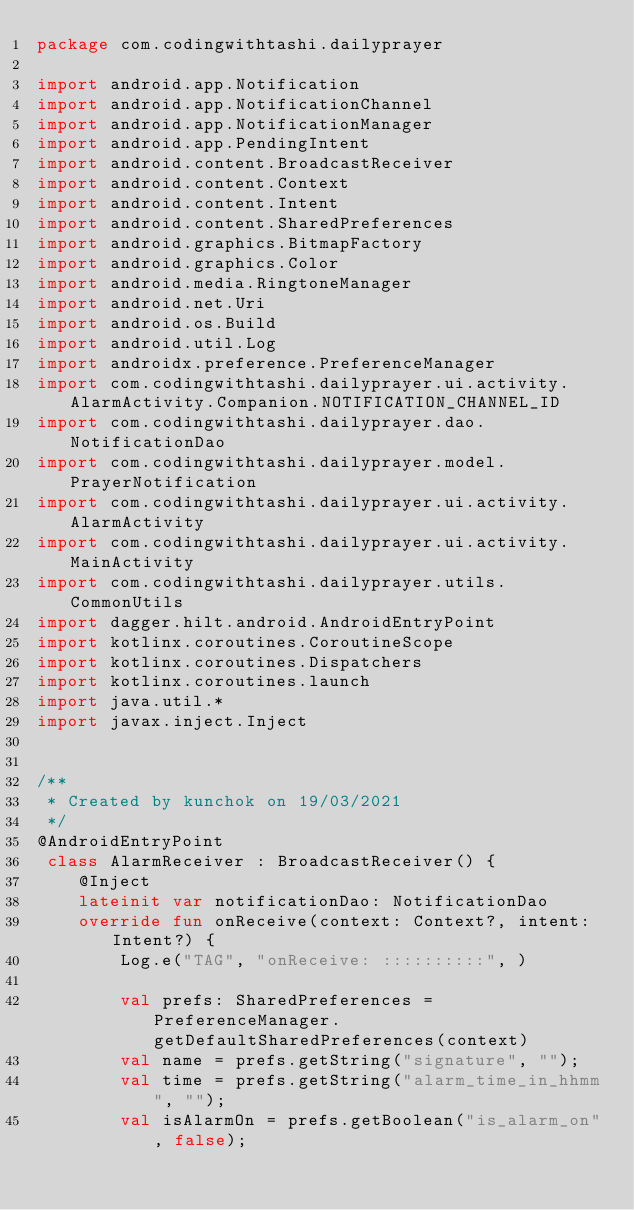Convert code to text. <code><loc_0><loc_0><loc_500><loc_500><_Kotlin_>package com.codingwithtashi.dailyprayer

import android.app.Notification
import android.app.NotificationChannel
import android.app.NotificationManager
import android.app.PendingIntent
import android.content.BroadcastReceiver
import android.content.Context
import android.content.Intent
import android.content.SharedPreferences
import android.graphics.BitmapFactory
import android.graphics.Color
import android.media.RingtoneManager
import android.net.Uri
import android.os.Build
import android.util.Log
import androidx.preference.PreferenceManager
import com.codingwithtashi.dailyprayer.ui.activity.AlarmActivity.Companion.NOTIFICATION_CHANNEL_ID
import com.codingwithtashi.dailyprayer.dao.NotificationDao
import com.codingwithtashi.dailyprayer.model.PrayerNotification
import com.codingwithtashi.dailyprayer.ui.activity.AlarmActivity
import com.codingwithtashi.dailyprayer.ui.activity.MainActivity
import com.codingwithtashi.dailyprayer.utils.CommonUtils
import dagger.hilt.android.AndroidEntryPoint
import kotlinx.coroutines.CoroutineScope
import kotlinx.coroutines.Dispatchers
import kotlinx.coroutines.launch
import java.util.*
import javax.inject.Inject


/**
 * Created by kunchok on 19/03/2021
 */
@AndroidEntryPoint
 class AlarmReceiver : BroadcastReceiver() {
    @Inject
    lateinit var notificationDao: NotificationDao
    override fun onReceive(context: Context?, intent: Intent?) {
        Log.e("TAG", "onReceive: ::::::::::", )

        val prefs: SharedPreferences = PreferenceManager.getDefaultSharedPreferences(context)
        val name = prefs.getString("signature", "");
        val time = prefs.getString("alarm_time_in_hhmm", "");
        val isAlarmOn = prefs.getBoolean("is_alarm_on", false);</code> 